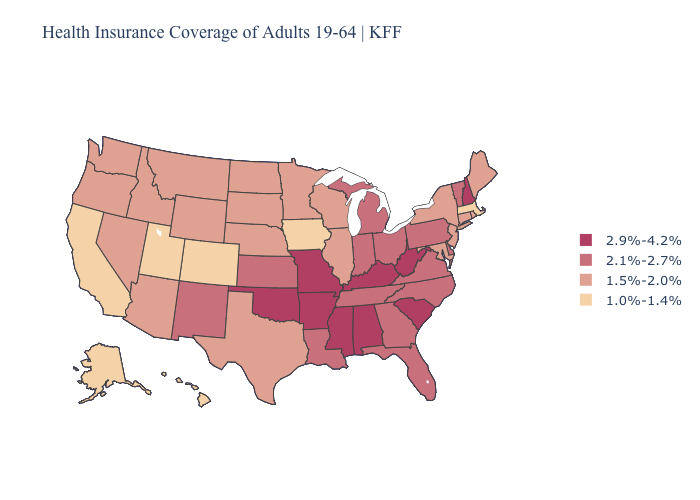Which states have the lowest value in the USA?
Give a very brief answer. Alaska, California, Colorado, Hawaii, Iowa, Massachusetts, Utah. Name the states that have a value in the range 1.5%-2.0%?
Be succinct. Arizona, Connecticut, Idaho, Illinois, Maine, Maryland, Minnesota, Montana, Nebraska, Nevada, New Jersey, New York, North Dakota, Oregon, Rhode Island, South Dakota, Texas, Washington, Wisconsin, Wyoming. Name the states that have a value in the range 2.9%-4.2%?
Give a very brief answer. Alabama, Arkansas, Kentucky, Mississippi, Missouri, New Hampshire, Oklahoma, South Carolina, West Virginia. Does Nevada have the lowest value in the West?
Answer briefly. No. What is the value of Louisiana?
Keep it brief. 2.1%-2.7%. Which states have the highest value in the USA?
Keep it brief. Alabama, Arkansas, Kentucky, Mississippi, Missouri, New Hampshire, Oklahoma, South Carolina, West Virginia. What is the value of Colorado?
Keep it brief. 1.0%-1.4%. Which states have the lowest value in the USA?
Write a very short answer. Alaska, California, Colorado, Hawaii, Iowa, Massachusetts, Utah. What is the value of Louisiana?
Give a very brief answer. 2.1%-2.7%. What is the value of Arkansas?
Concise answer only. 2.9%-4.2%. What is the value of South Dakota?
Write a very short answer. 1.5%-2.0%. What is the highest value in states that border Arkansas?
Be succinct. 2.9%-4.2%. Name the states that have a value in the range 1.0%-1.4%?
Quick response, please. Alaska, California, Colorado, Hawaii, Iowa, Massachusetts, Utah. What is the highest value in states that border Arizona?
Quick response, please. 2.1%-2.7%. Which states have the lowest value in the MidWest?
Concise answer only. Iowa. 